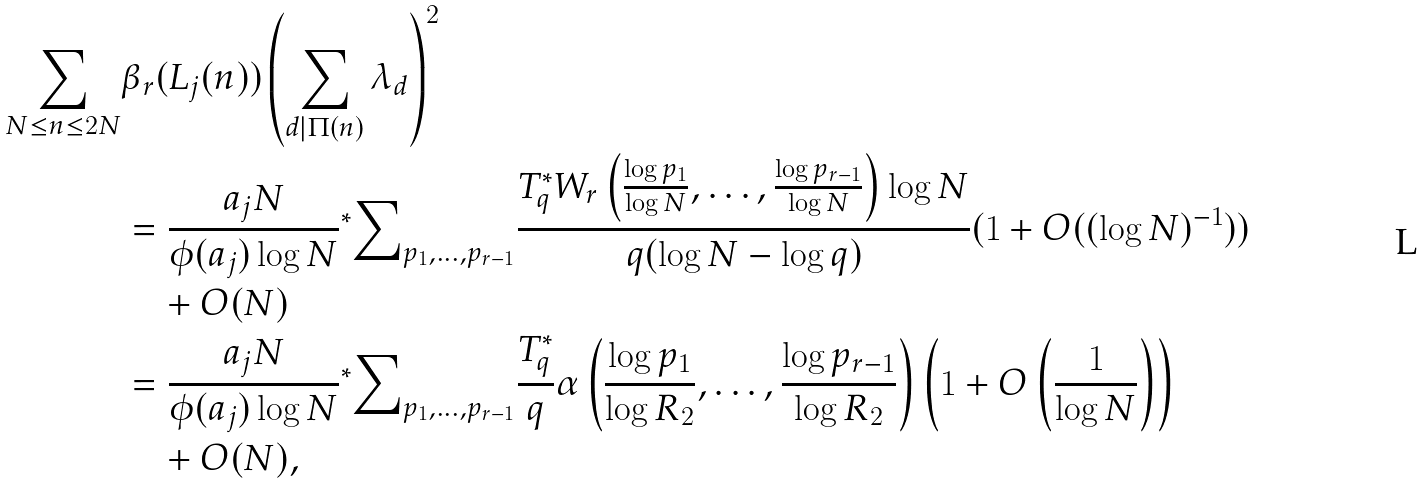Convert formula to latex. <formula><loc_0><loc_0><loc_500><loc_500>\sum _ { N \leq n \leq 2 N } & \beta _ { r } ( L _ { j } ( n ) ) \left ( \sum _ { d | \Pi ( n ) } \lambda _ { d } \right ) ^ { 2 } \\ & = \frac { a _ { j } N } { \phi ( a _ { j } ) \log { N } } { ^ { * } } { \sum } _ { p _ { 1 } , \dots , p _ { r - 1 } } \frac { T ^ { * } _ { q } W _ { r } \left ( \frac { \log { p _ { 1 } } } { \log { N } } , \dots , \frac { \log { p _ { r - 1 } } } { \log { N } } \right ) \log { N } } { q ( \log { N } - \log { q } ) } ( 1 + O ( ( \log { N } ) ^ { - 1 } ) ) \\ & \quad + O ( N ) \\ & = \frac { a _ { j } N } { \phi ( a _ { j } ) \log { N } } { ^ { * } } { \sum } _ { p _ { 1 } , \dots , p _ { r - 1 } } \frac { T ^ { * } _ { q } } { q } \alpha \left ( \frac { \log { p _ { 1 } } } { \log { R _ { 2 } } } , \dots , \frac { \log { p _ { r - 1 } } } { \log { R _ { 2 } } } \right ) \left ( 1 + O \left ( \frac { 1 } { \log { N } } \right ) \right ) \\ & \quad + O ( N ) ,</formula> 